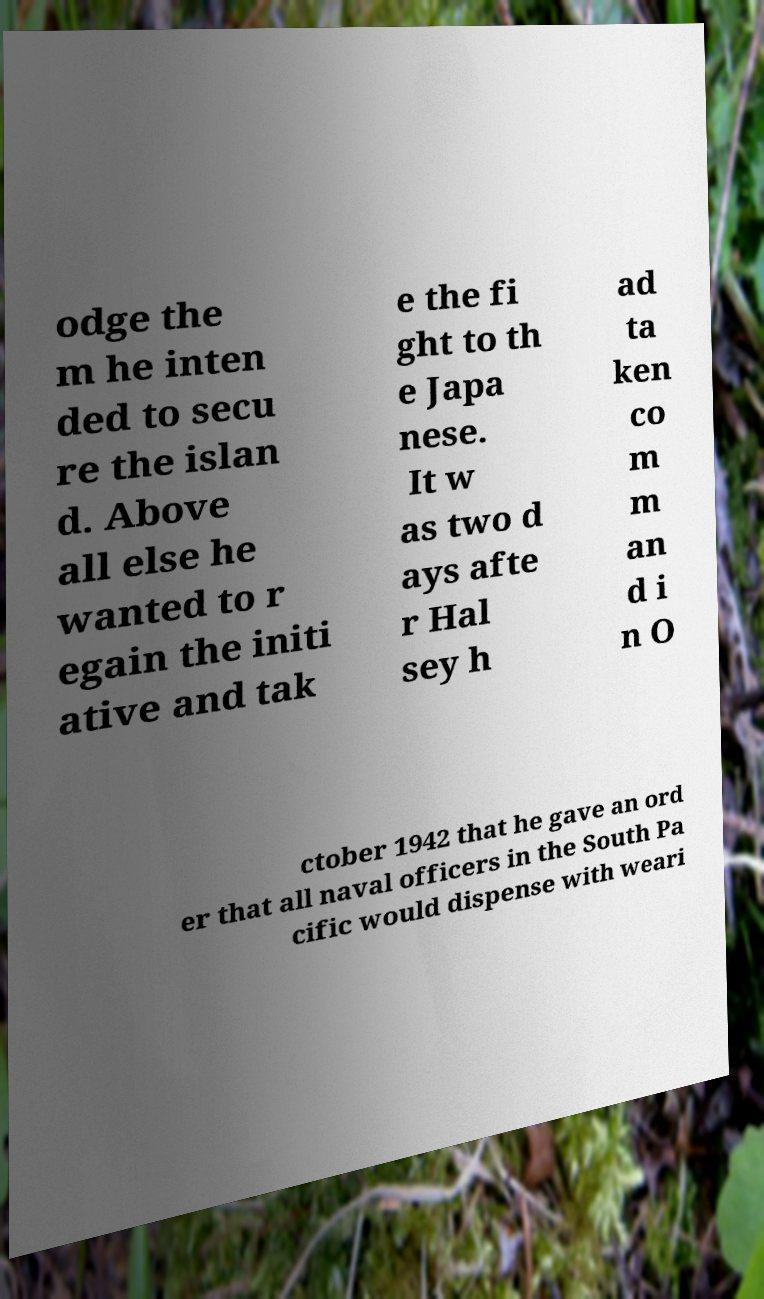There's text embedded in this image that I need extracted. Can you transcribe it verbatim? odge the m he inten ded to secu re the islan d. Above all else he wanted to r egain the initi ative and tak e the fi ght to th e Japa nese. It w as two d ays afte r Hal sey h ad ta ken co m m an d i n O ctober 1942 that he gave an ord er that all naval officers in the South Pa cific would dispense with weari 